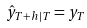Convert formula to latex. <formula><loc_0><loc_0><loc_500><loc_500>\hat { y } _ { T + h | T } = y _ { T }</formula> 